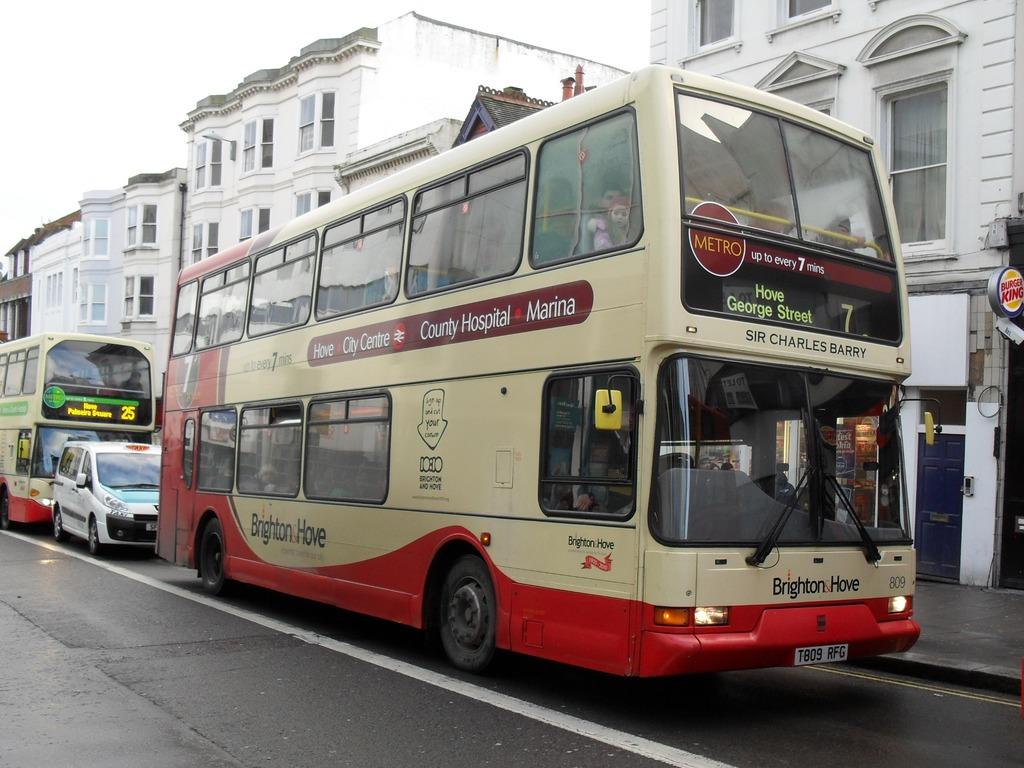What's the big number on the front of this bus at the top?
Your response must be concise. 7. What street is this bus going to?
Provide a short and direct response. George. 